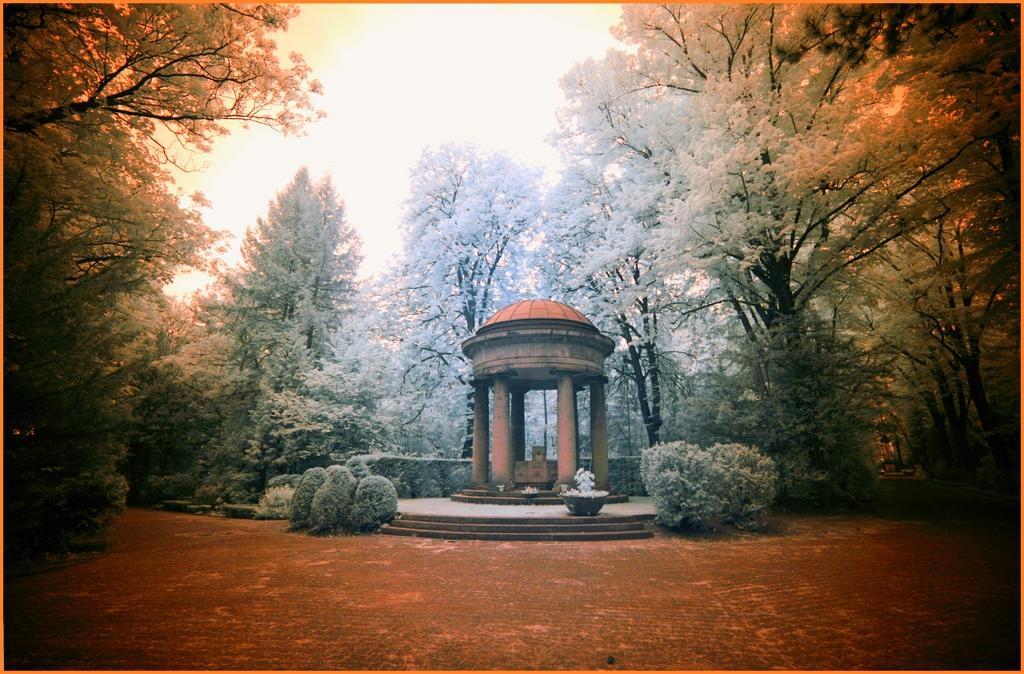How would you summarize this image in a sentence or two? In this picture we can see a shed on the ground, here we can see a houseplant, plants, trees and some objects and we can see sky in the background. 